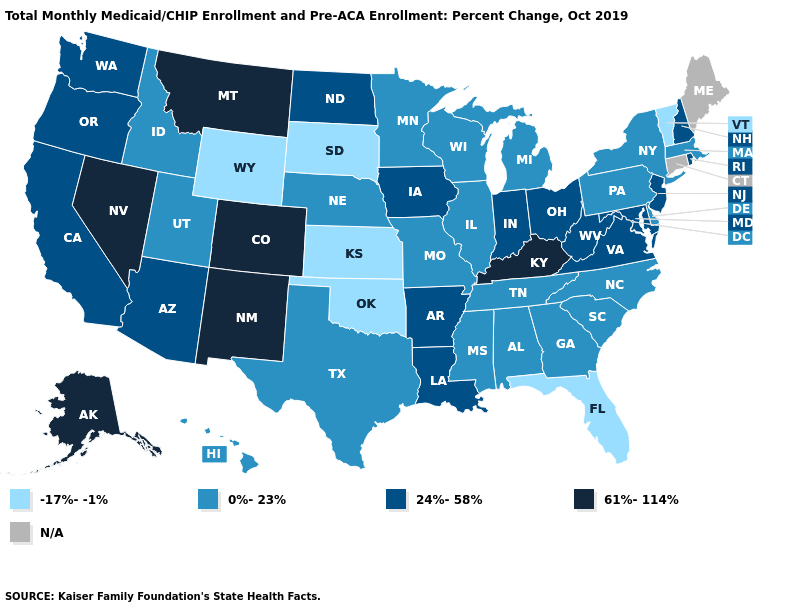Which states hav the highest value in the West?
Answer briefly. Alaska, Colorado, Montana, Nevada, New Mexico. Among the states that border Vermont , which have the lowest value?
Be succinct. Massachusetts, New York. What is the value of Oregon?
Be succinct. 24%-58%. Name the states that have a value in the range -17%--1%?
Concise answer only. Florida, Kansas, Oklahoma, South Dakota, Vermont, Wyoming. What is the value of Vermont?
Write a very short answer. -17%--1%. Which states have the lowest value in the USA?
Write a very short answer. Florida, Kansas, Oklahoma, South Dakota, Vermont, Wyoming. Which states have the highest value in the USA?
Keep it brief. Alaska, Colorado, Kentucky, Montana, Nevada, New Mexico. Name the states that have a value in the range -17%--1%?
Concise answer only. Florida, Kansas, Oklahoma, South Dakota, Vermont, Wyoming. What is the highest value in states that border California?
Quick response, please. 61%-114%. What is the value of Minnesota?
Quick response, please. 0%-23%. What is the value of New Mexico?
Answer briefly. 61%-114%. What is the value of Kansas?
Concise answer only. -17%--1%. Does the first symbol in the legend represent the smallest category?
Be succinct. Yes. Name the states that have a value in the range 0%-23%?
Answer briefly. Alabama, Delaware, Georgia, Hawaii, Idaho, Illinois, Massachusetts, Michigan, Minnesota, Mississippi, Missouri, Nebraska, New York, North Carolina, Pennsylvania, South Carolina, Tennessee, Texas, Utah, Wisconsin. 